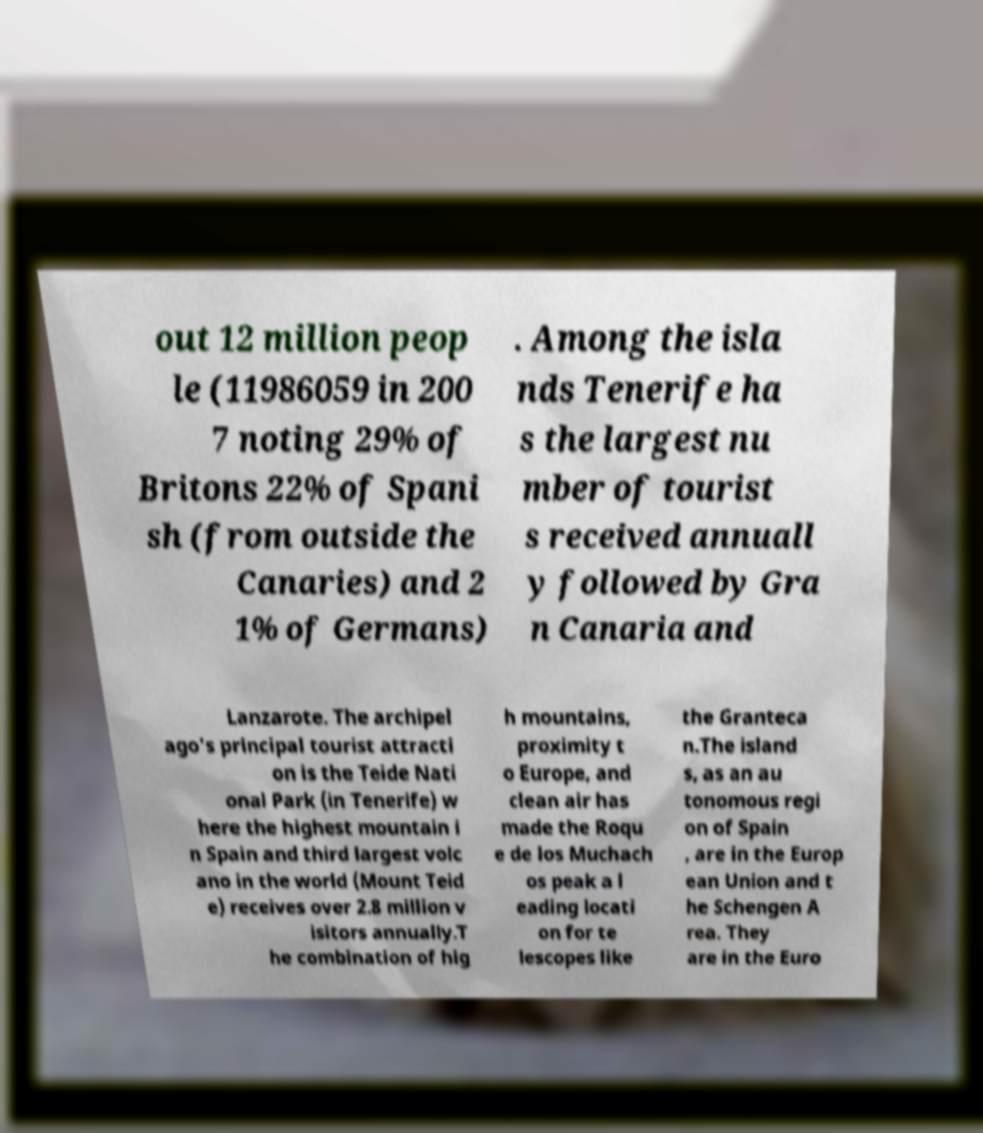Can you read and provide the text displayed in the image?This photo seems to have some interesting text. Can you extract and type it out for me? out 12 million peop le (11986059 in 200 7 noting 29% of Britons 22% of Spani sh (from outside the Canaries) and 2 1% of Germans) . Among the isla nds Tenerife ha s the largest nu mber of tourist s received annuall y followed by Gra n Canaria and Lanzarote. The archipel ago's principal tourist attracti on is the Teide Nati onal Park (in Tenerife) w here the highest mountain i n Spain and third largest volc ano in the world (Mount Teid e) receives over 2.8 million v isitors annually.T he combination of hig h mountains, proximity t o Europe, and clean air has made the Roqu e de los Muchach os peak a l eading locati on for te lescopes like the Granteca n.The island s, as an au tonomous regi on of Spain , are in the Europ ean Union and t he Schengen A rea. They are in the Euro 